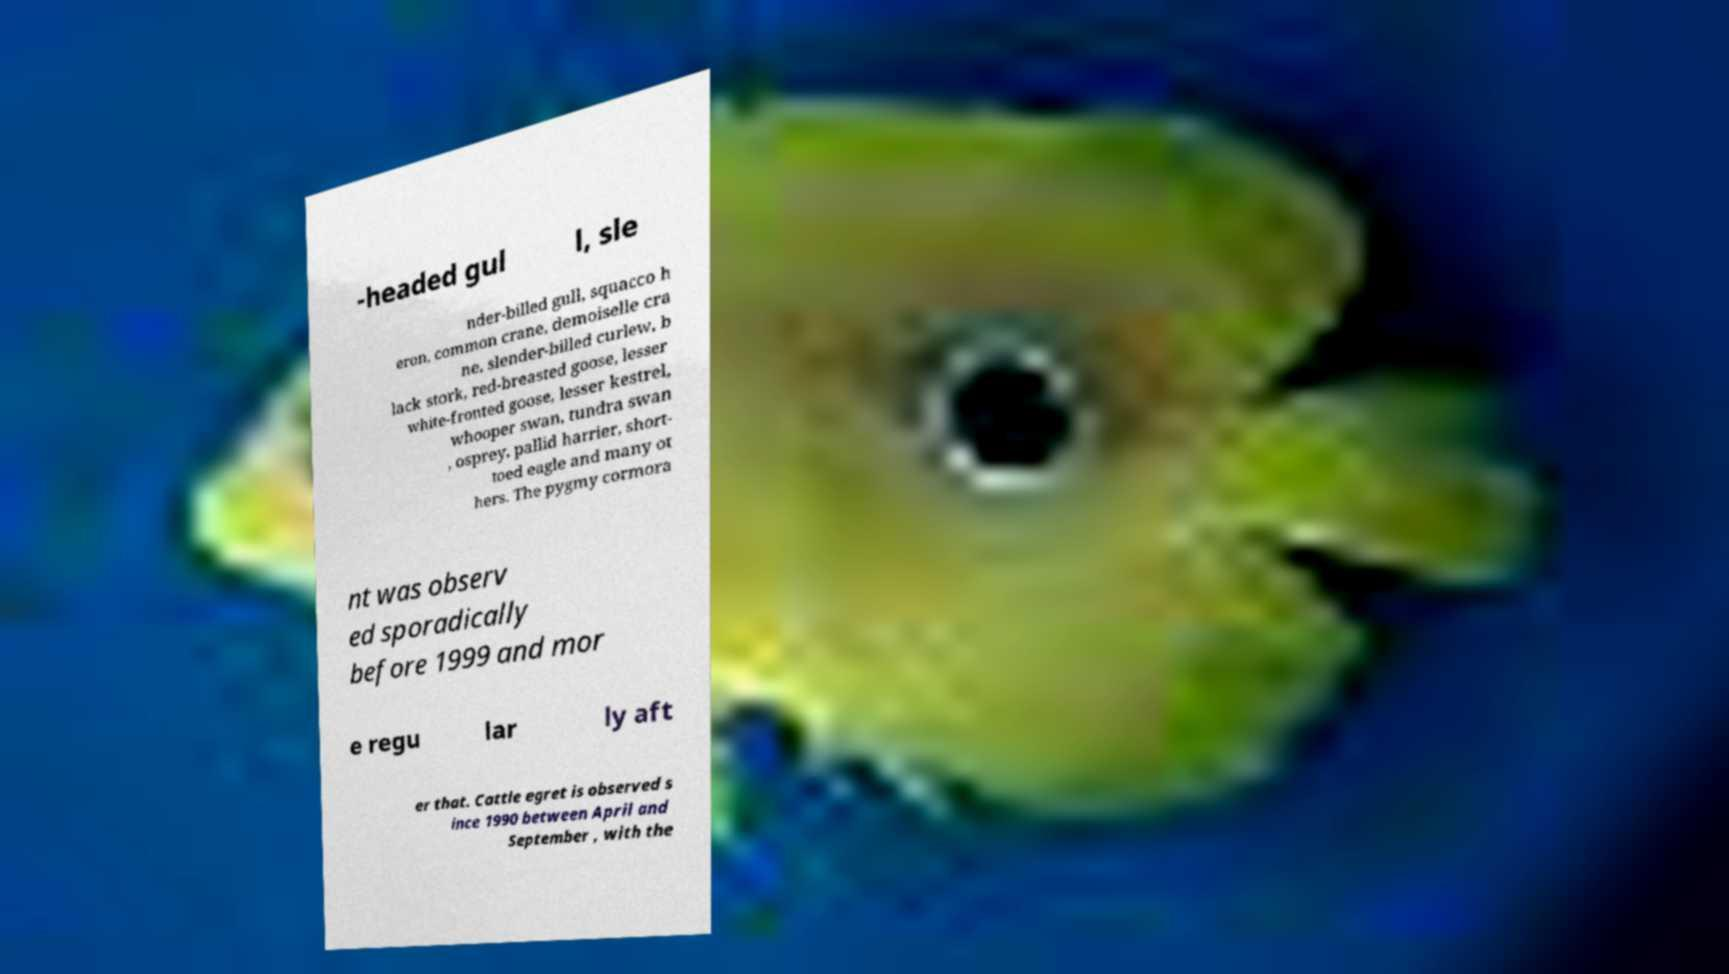Could you assist in decoding the text presented in this image and type it out clearly? -headed gul l, sle nder-billed gull, squacco h eron, common crane, demoiselle cra ne, slender-billed curlew, b lack stork, red-breasted goose, lesser white-fronted goose, lesser kestrel, whooper swan, tundra swan , osprey, pallid harrier, short- toed eagle and many ot hers. The pygmy cormora nt was observ ed sporadically before 1999 and mor e regu lar ly aft er that. Cattle egret is observed s ince 1990 between April and September , with the 